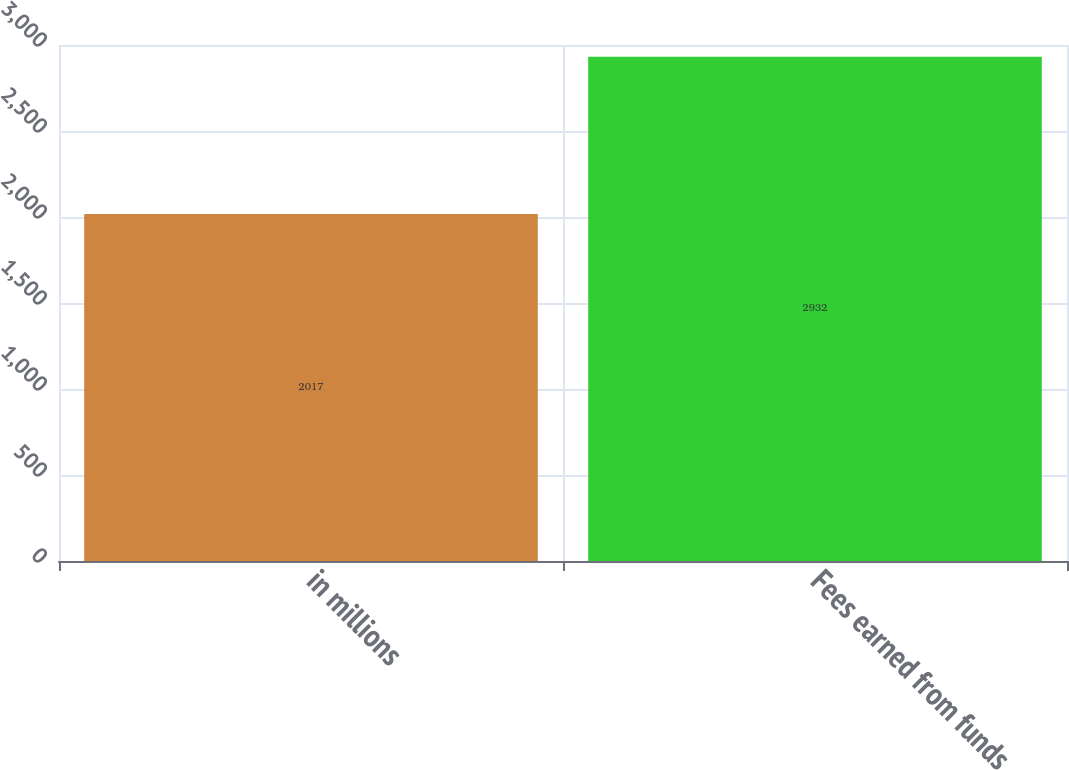Convert chart to OTSL. <chart><loc_0><loc_0><loc_500><loc_500><bar_chart><fcel>in millions<fcel>Fees earned from funds<nl><fcel>2017<fcel>2932<nl></chart> 